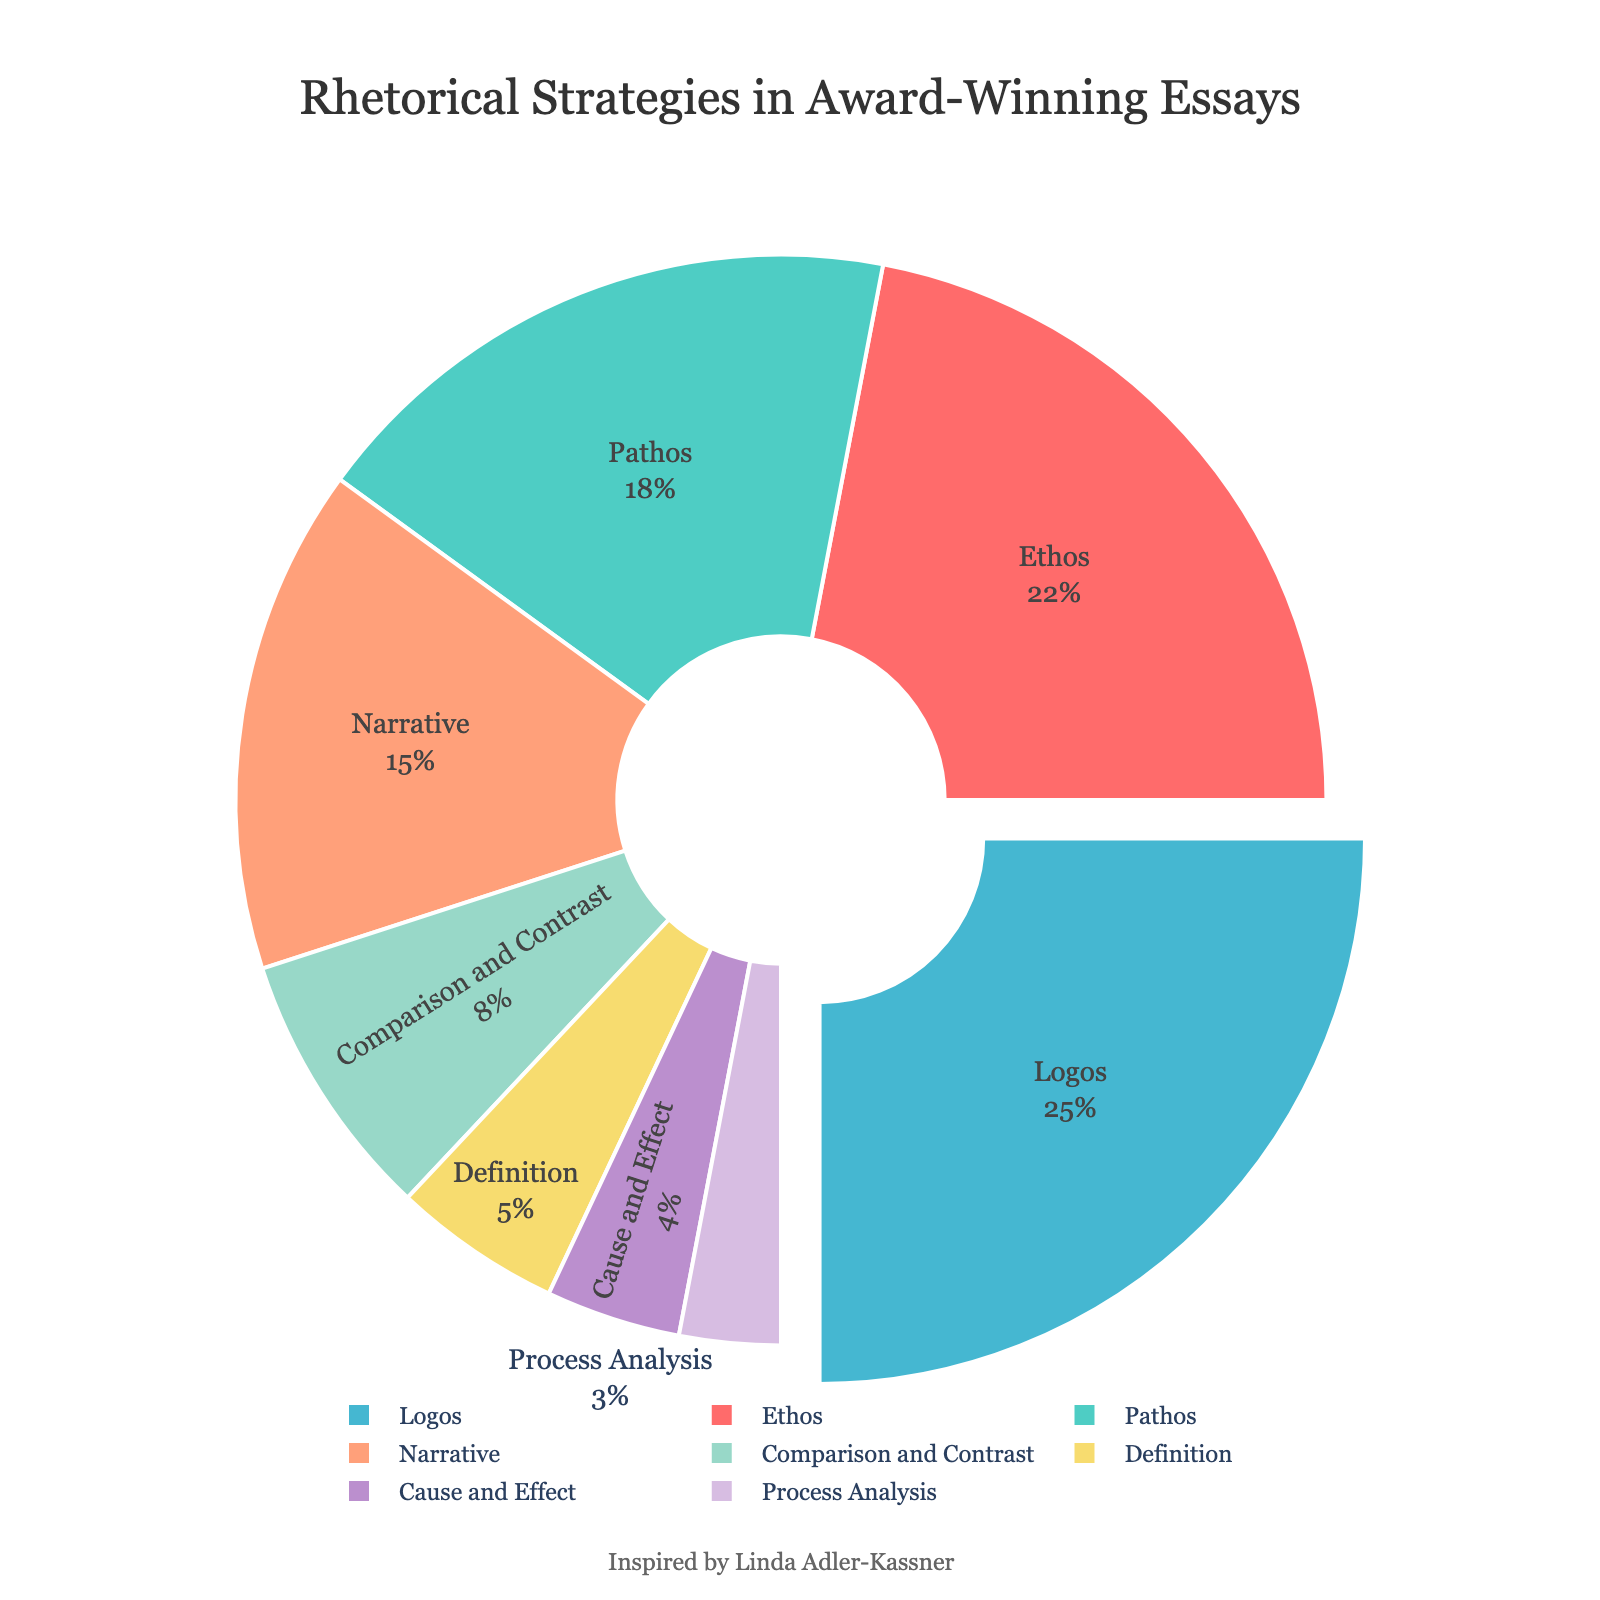Which rhetorical strategy is used the most in award-winning essays? The pie chart indicates that Logos is the strategy with the highest proportion, highlighted by the segment slightly pulled out.
Answer: Logos Which rhetorical strategy has the smallest percentage? The pie chart shows that Process Analysis has the smallest percentage, identified by the smallest segment.
Answer: Process Analysis What is the combined percentage of Ethos and Pathos? The chart shows Ethos at 22% and Pathos at 18%. Summing these values: 22% + 18% = 40%.
Answer: 40% How does the use of Narrative compare to Comparison and Contrast? Narrative has 15% and Comparison and Contrast has 8%, making Narrative nearly twice as common.
Answer: Narrative is nearly twice as common What is the median percentage of the rhetorical strategies? Ordering from smallest to largest: Process Analysis (3%), Cause and Effect (4%), Definition (5%), Comparison and Contrast (8%), Narrative (15%), Pathos (18%), Ethos (22%), Logos (25%). The middle two values are Comparison and Contrast (8%) and Narrative (15%). The median is their average: (8% + 15%)/2 = 11.5%.
Answer: 11.5% Which two strategies together make up a quarter of the total proportions? Examining the percentages, Cause and Effect (4%) and Process Analysis (3%) together make 7%, which is less than 25%. Definition (5%) and Cause and Effect (4%) make 9%, still less. Definition (5%) and Comparison and Contrast (8%) make 13%. Narrative (15%) and Cause and Effect (4%) make 19%. Pathos (18%) and Cause and Effect (4%) make 22%, which is close. Pathos (18%) and Process Analysis (3%) make 21%. Logos (25%) alone makes up 25%. Thus, Logos alone fits.
Answer: Logos Which two strategies combined have a higher percentage than Pathos? Pathos has 18%. Checking combinations: Process Analysis (3%) and Cause and Effect (4%) combine for 7%. Definition (5%) and Process Analysis (3%) combine for 8%. Comparison and Contrast (8%) and Process Analysis (3%) combine for 11%. Narrative (15%) and Process Analysis (3%) make 18%. Ethos (22%) and any percentage would exceed 18%; hence Ethos on its own is higher.
Answer: Ethos alone is higher What color represents the 'Ethos' segment? The chart uses distinct colors for each strategy. Ethos is depicted in red.
Answer: Red 